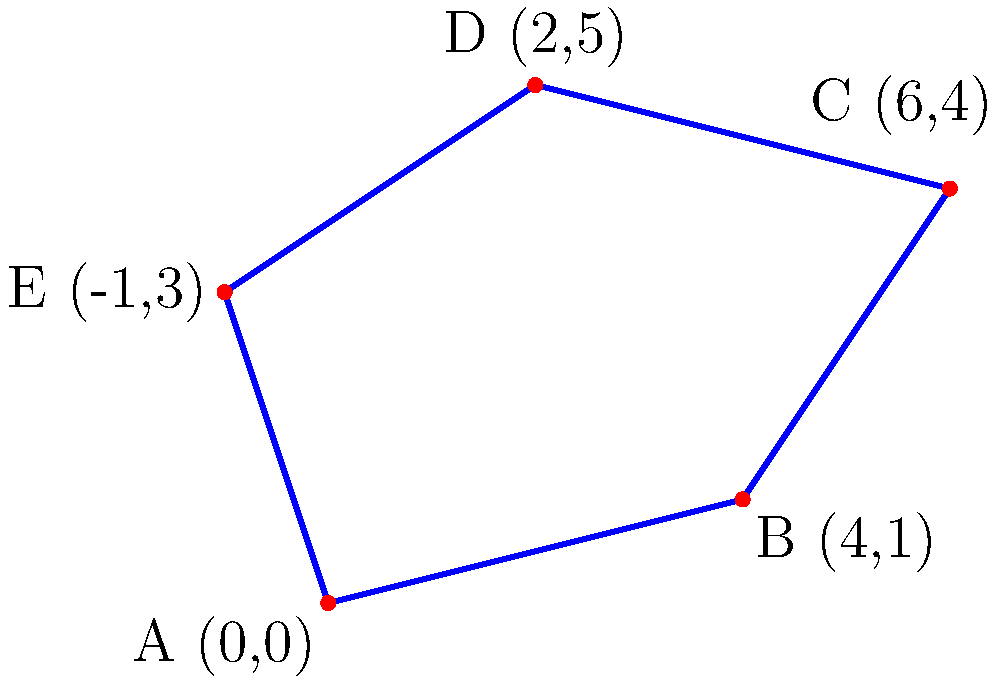As a student studying the history of World War II battlefields, you've been tasked with calculating the perimeter of an irregularly shaped battlefield given its coordinates. The battlefield is represented by the blue shape in the diagram, with vertices A(0,0), B(4,1), C(6,4), D(2,5), and E(-1,3). Calculate the perimeter of this battlefield to the nearest meter. To calculate the perimeter of the irregular battlefield, we need to find the sum of the distances between consecutive points. We'll use the distance formula between two points: $d = \sqrt{(x_2-x_1)^2 + (y_2-y_1)^2}$

Step 1: Calculate AB
$AB = \sqrt{(4-0)^2 + (1-0)^2} = \sqrt{16 + 1} = \sqrt{17}$

Step 2: Calculate BC
$BC = \sqrt{(6-4)^2 + (4-1)^2} = \sqrt{4 + 9} = \sqrt{13}$

Step 3: Calculate CD
$CD = \sqrt{(2-6)^2 + (5-4)^2} = \sqrt{16 + 1} = \sqrt{17}$

Step 4: Calculate DE
$DE = \sqrt{(-1-2)^2 + (3-5)^2} = \sqrt{9 + 4} = \sqrt{13}$

Step 5: Calculate EA
$EA = \sqrt{(0-(-1))^2 + (0-3)^2} = \sqrt{1 + 9} = \sqrt{10}$

Step 6: Sum all distances
Perimeter = $\sqrt{17} + \sqrt{13} + \sqrt{17} + \sqrt{13} + \sqrt{10}$

Step 7: Simplify and round to the nearest meter
Perimeter $\approx 4.12 + 3.61 + 4.12 + 3.61 + 3.16 = 18.62$ meters

Rounding to the nearest meter: 19 meters
Answer: 19 meters 